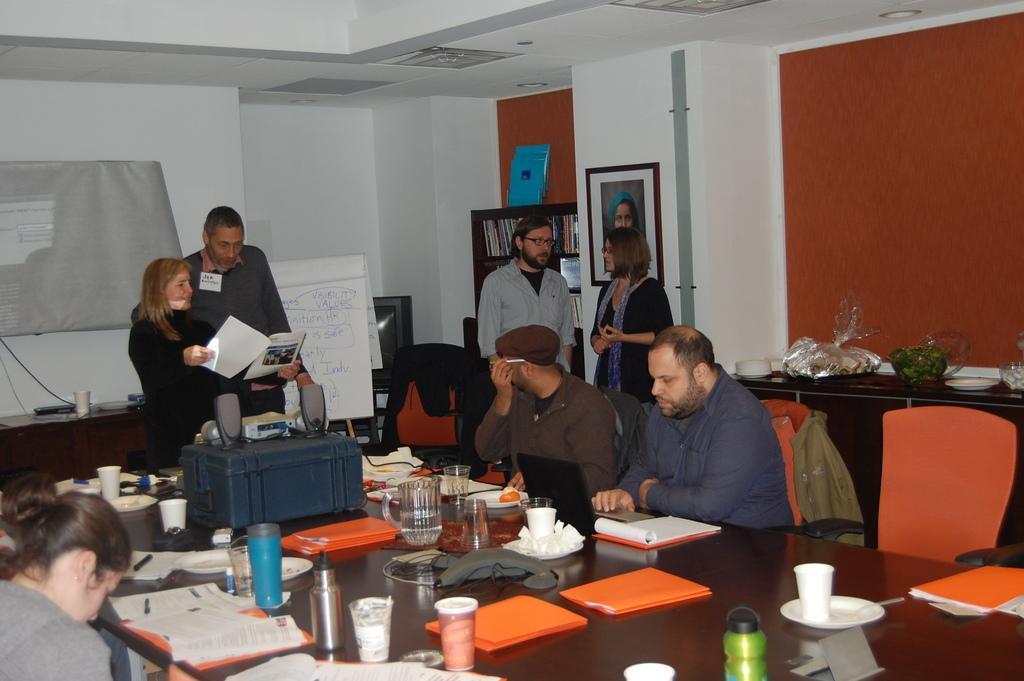Can you describe this image briefly? In this image, we can see people, chairs, table, desks, board and a few objects. In the background, we can see wall, sheet, photo frame, book racks, television and few objects. Few people sitting on the chairs. On the left side of the image, we can see a woman holding papers. At the bottom of the image, there are so many things and objects are placed on the table. 